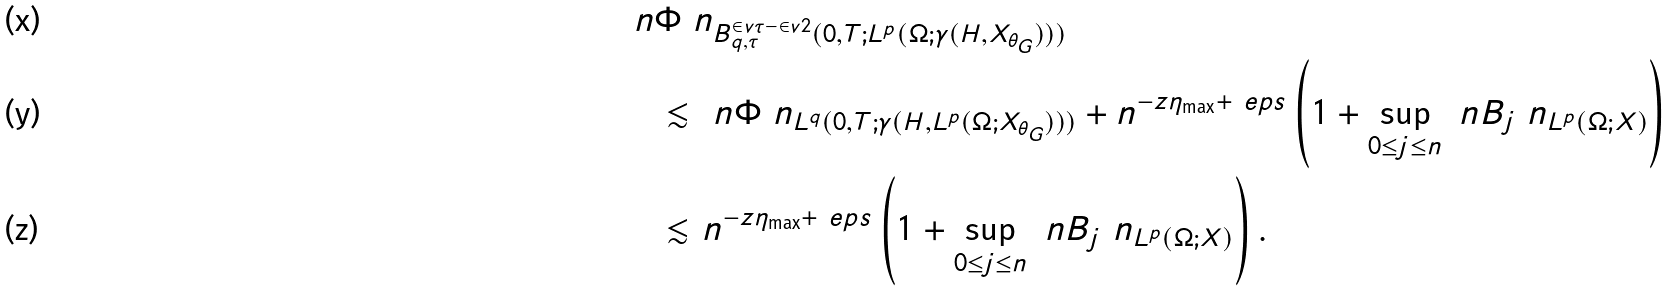Convert formula to latex. <formula><loc_0><loc_0><loc_500><loc_500>& \ n \Phi \ n _ { B ^ { \in v { \tau } - \in v { 2 } } _ { q , \tau } ( 0 , T ; L ^ { p } ( \Omega ; \gamma ( H , X _ { \theta _ { G } } ) ) ) } \\ & \quad \lesssim \ n \Phi \ n _ { L ^ { q } ( 0 , T ; \gamma ( H , L ^ { p } ( \Omega ; X _ { \theta _ { G } } ) ) ) } + n ^ { - z \eta _ { \max } + \ e p s } \left ( 1 + \sup _ { 0 \leq j \leq n } \ n B _ { j } \ n _ { L ^ { p } ( \Omega ; X ) } \right ) \\ & \quad \lesssim n ^ { - z \eta _ { \max } + \ e p s } \left ( 1 + \sup _ { 0 \leq j \leq n } \ n B _ { j } \ n _ { L ^ { p } ( \Omega ; X ) } \right ) .</formula> 